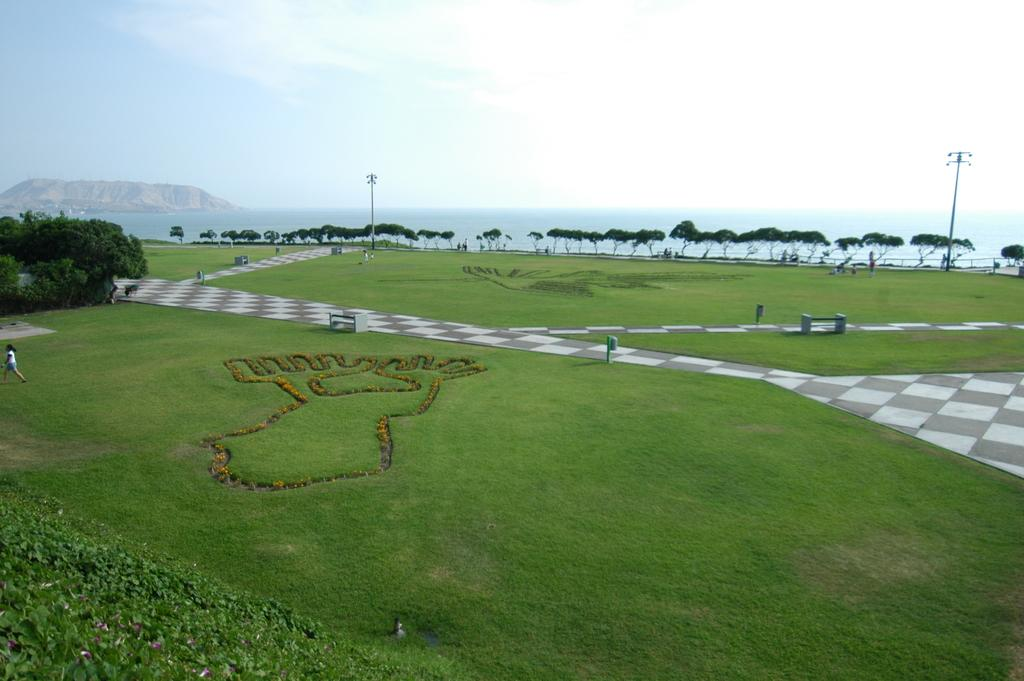What type of terrain is visible in the image? The image contains land full of grass. What can be seen in the background of the image? There are trees in the background of the image. What body of water is visible in the image? The sea is visible in the image. What geographical feature can be seen in the image? There are mountains in the image. Where is the pie located in the image? There is no pie present in the image. Can you describe the cemetery in the image? There is no cemetery present in the image. 